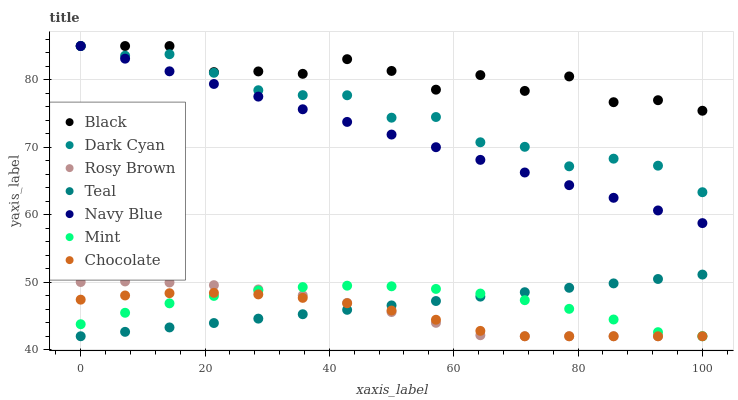Does Chocolate have the minimum area under the curve?
Answer yes or no. Yes. Does Black have the maximum area under the curve?
Answer yes or no. Yes. Does Rosy Brown have the minimum area under the curve?
Answer yes or no. No. Does Rosy Brown have the maximum area under the curve?
Answer yes or no. No. Is Teal the smoothest?
Answer yes or no. Yes. Is Black the roughest?
Answer yes or no. Yes. Is Rosy Brown the smoothest?
Answer yes or no. No. Is Rosy Brown the roughest?
Answer yes or no. No. Does Rosy Brown have the lowest value?
Answer yes or no. Yes. Does Black have the lowest value?
Answer yes or no. No. Does Dark Cyan have the highest value?
Answer yes or no. Yes. Does Rosy Brown have the highest value?
Answer yes or no. No. Is Mint less than Black?
Answer yes or no. Yes. Is Black greater than Teal?
Answer yes or no. Yes. Does Dark Cyan intersect Navy Blue?
Answer yes or no. Yes. Is Dark Cyan less than Navy Blue?
Answer yes or no. No. Is Dark Cyan greater than Navy Blue?
Answer yes or no. No. Does Mint intersect Black?
Answer yes or no. No. 